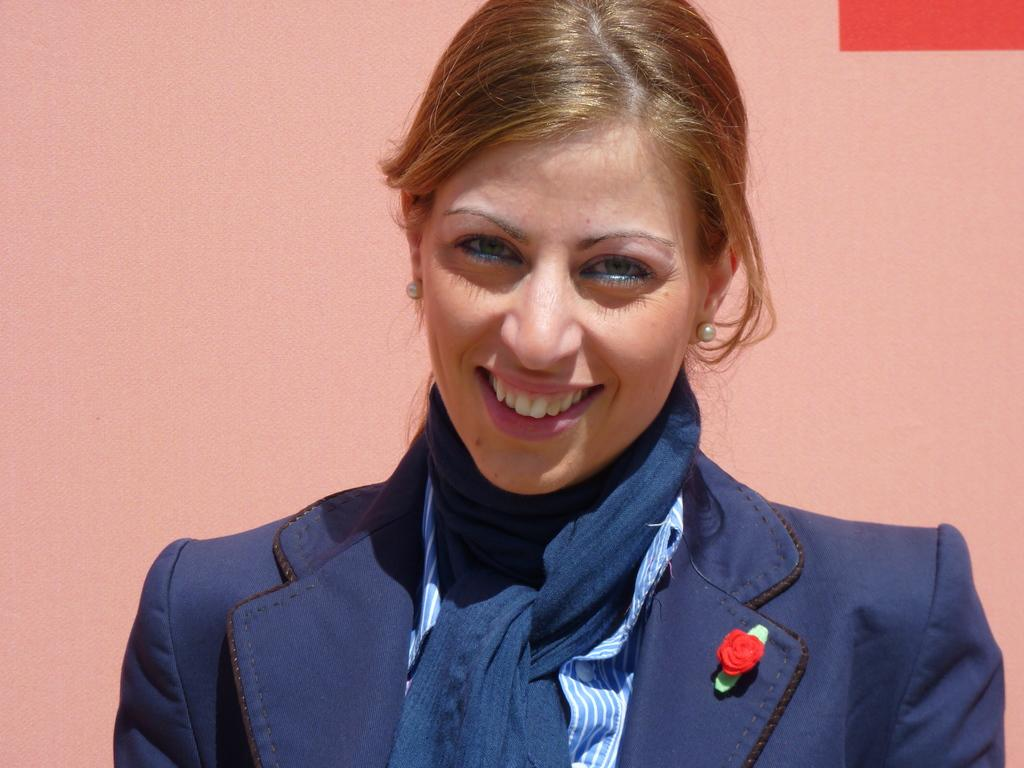Who is present in the image? There is a woman in the image. What is the woman doing in the image? The woman is standing in the image. What is the woman's facial expression in the image? The woman is smiling in the image. What is the woman wearing in the image? The woman is wearing a blue coat and a blue scarf in the image. What can be seen in the background of the image? There is a light pink color wall in the background of the image. What flavor of dinosaur is the woman holding in the image? There are no dinosaurs present in the image, and therefore no flavor can be determined. How many kittens are visible on the woman's shoulder in the image? There are no kittens visible on the woman's shoulder or anywhere else in the image. 